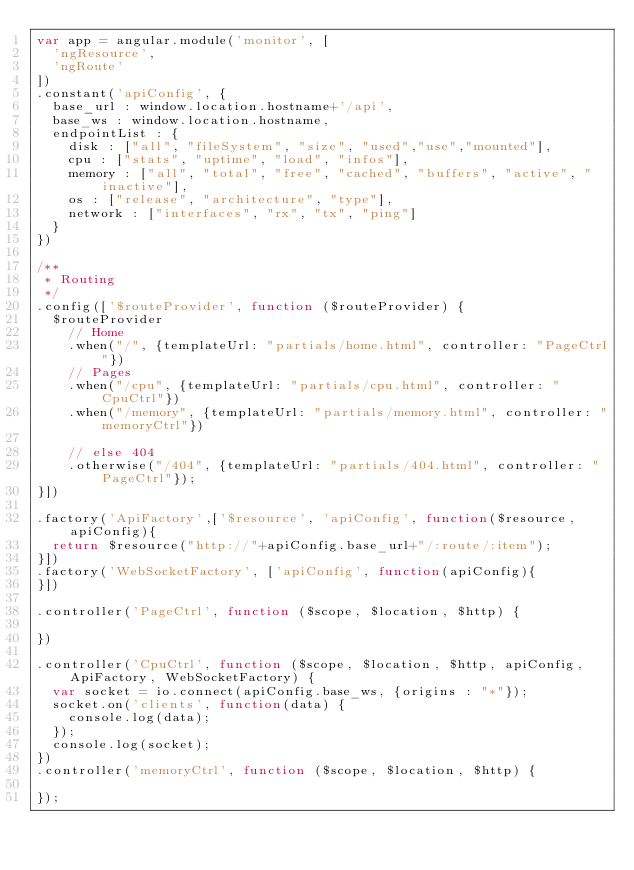<code> <loc_0><loc_0><loc_500><loc_500><_JavaScript_>var app = angular.module('monitor', [
	'ngResource',
	'ngRoute'
])
.constant('apiConfig', {
	base_url : window.location.hostname+'/api',
	base_ws : window.location.hostname,
	endpointList : {
		disk : ["all", "fileSystem", "size", "used","use","mounted"],
		cpu : ["stats", "uptime", "load", "infos"],
		memory : ["all", "total", "free", "cached", "buffers", "active", "inactive"],
		os : ["release", "architecture", "type"],
		network : ["interfaces", "rx", "tx", "ping"]
	}
})

/**
 * Routing
 */
.config(['$routeProvider', function ($routeProvider) {
	$routeProvider
		// Home
		.when("/", {templateUrl: "partials/home.html", controller: "PageCtrl"})
		// Pages
		.when("/cpu", {templateUrl: "partials/cpu.html", controller: "CpuCtrl"})
		.when("/memory", {templateUrl: "partials/memory.html", controller: "memoryCtrl"})

		// else 404
		.otherwise("/404", {templateUrl: "partials/404.html", controller: "PageCtrl"});
}])

.factory('ApiFactory',['$resource', 'apiConfig', function($resource, apiConfig){
	return $resource("http://"+apiConfig.base_url+"/:route/:item");
}])
.factory('WebSocketFactory', ['apiConfig', function(apiConfig){
}])

.controller('PageCtrl', function ($scope, $location, $http) {

})

.controller('CpuCtrl', function ($scope, $location, $http, apiConfig, ApiFactory, WebSocketFactory) {
	var socket = io.connect(apiConfig.base_ws, {origins : "*"});
	socket.on('clients', function(data) {
		console.log(data);
	});
	console.log(socket);
})
.controller('memoryCtrl', function ($scope, $location, $http) {
	
});</code> 